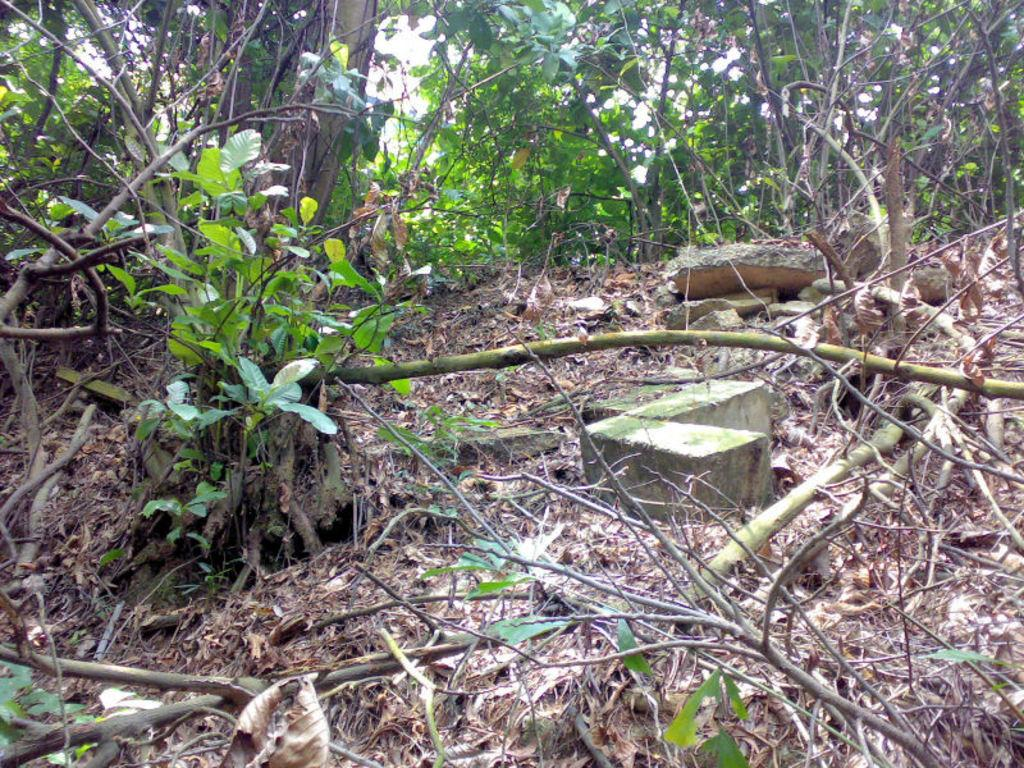What type of natural elements can be seen in the image? There are rocks, plants, and trees in the image. Can you describe the vegetation present in the image? The image contains plants and trees. What is the primary difference between the plants and trees in the image? The trees are typically taller and have a more defined trunk compared to the plants. What type of soup is being served in the image? There is no soup present in the image; it features rocks, plants, and trees. How many kittens can be seen playing with the insect in the image? There are no kittens or insects present in the image. 